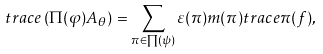Convert formula to latex. <formula><loc_0><loc_0><loc_500><loc_500>t r a c e \left ( \Pi ( \varphi ) A _ { \theta } \right ) = \sum _ { \pi \in \prod ( \psi ) } \varepsilon ( \pi ) m ( \pi ) t r a c e \pi ( f ) ,</formula> 